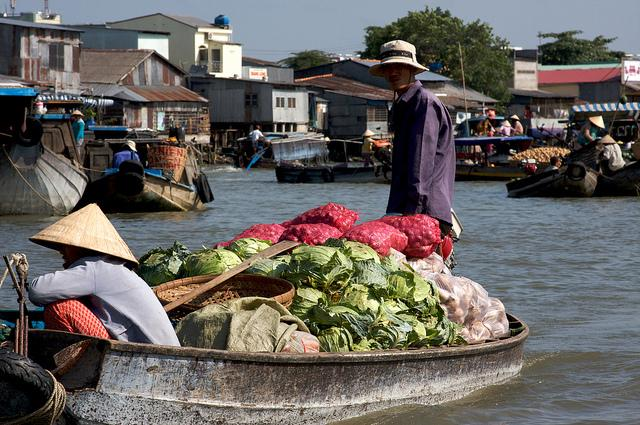What kind of boat is this? transport 